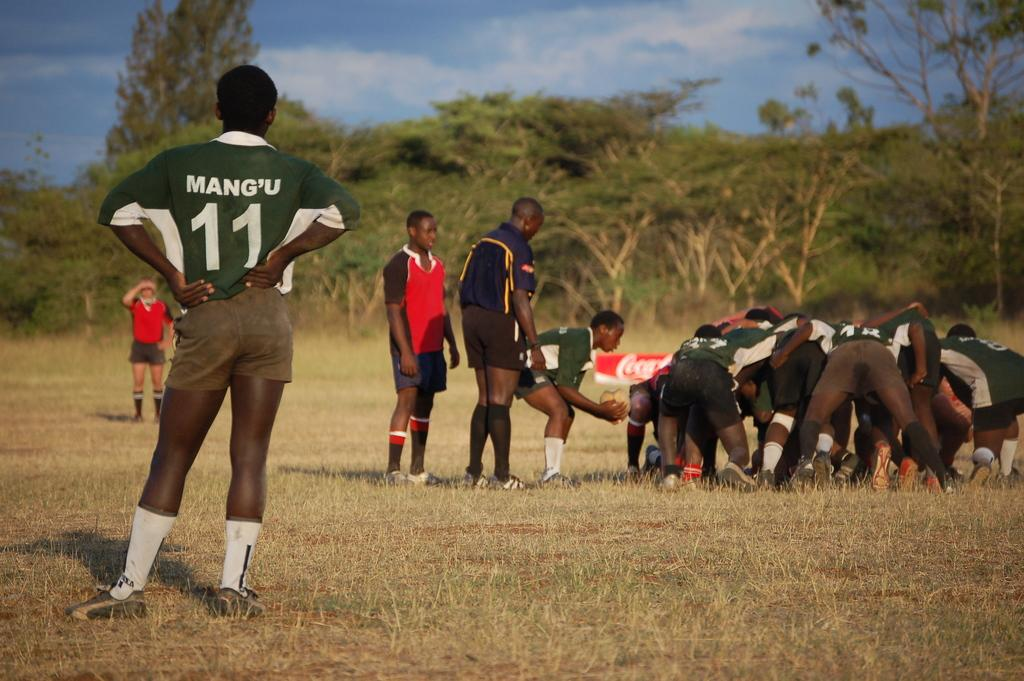<image>
Present a compact description of the photo's key features. Group of people playing a sport with a man number 11 watching on. 